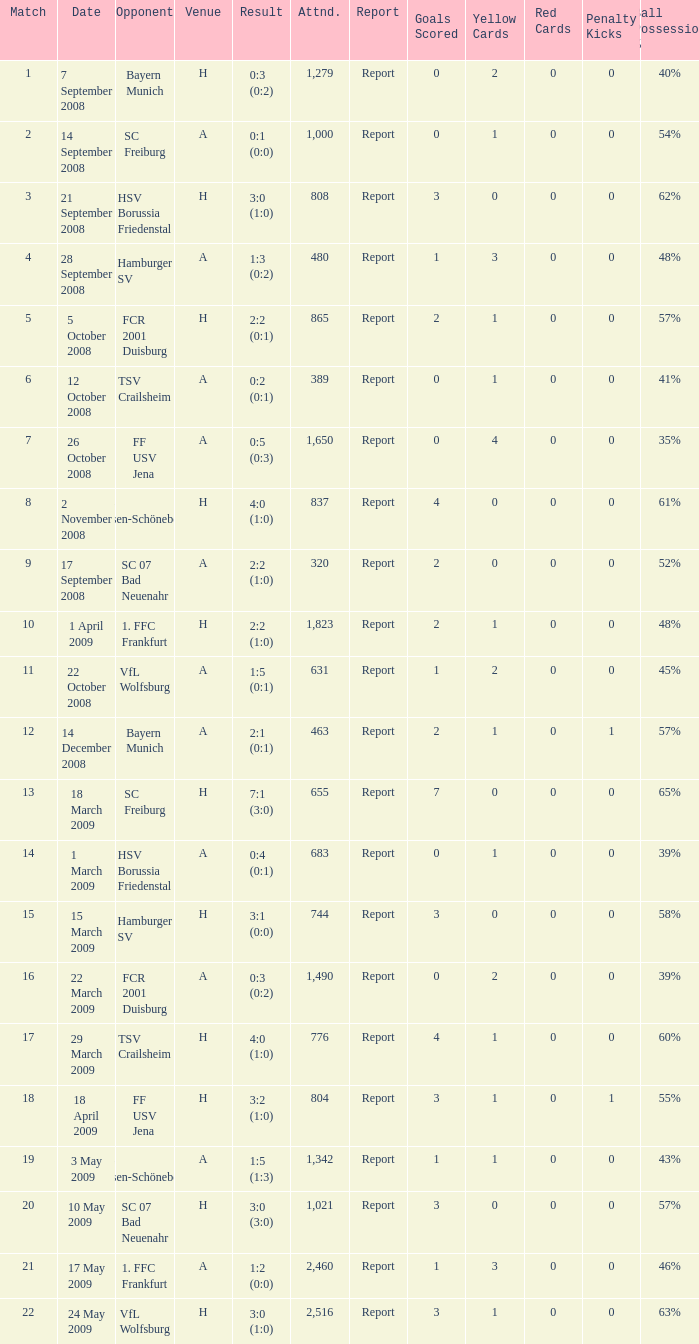What is the fixture number that produced a result of 0:5 (0:3)? 1.0. 